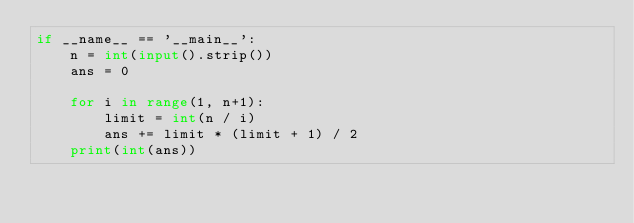Convert code to text. <code><loc_0><loc_0><loc_500><loc_500><_Python_>if __name__ == '__main__':
    n = int(input().strip())
    ans = 0

    for i in range(1, n+1):
        limit = int(n / i)
        ans += limit * (limit + 1) / 2
    print(int(ans))</code> 